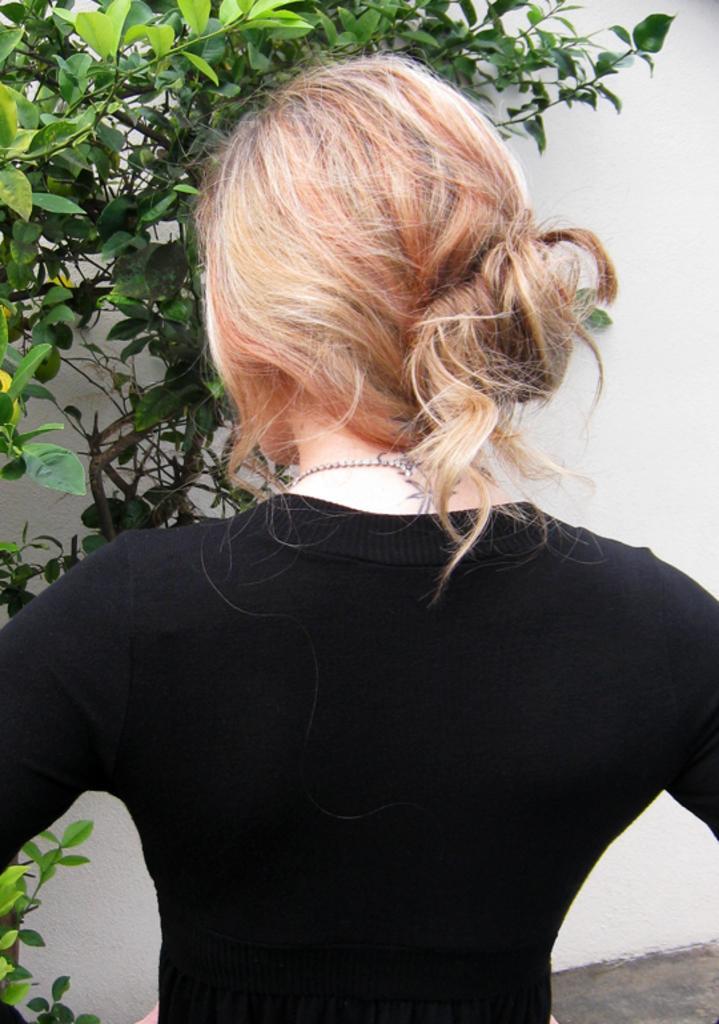Can you describe this image briefly? In this picture I can see there is a woman standing she is wearing a black t-shirt and he is wearing a chain and has a tattoo on her neck and there is a plant in the backdrop and the sky is clear. 